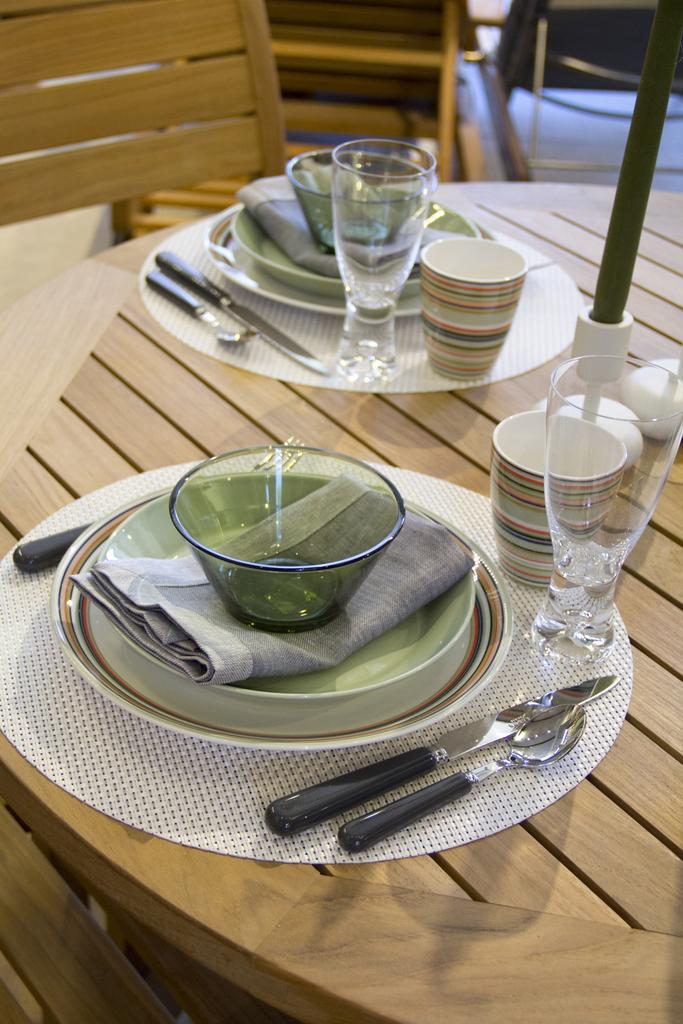What type of table is in the image? There is a brown table in the image. What objects are placed on the table? There are plates, glasses, and cups on the table. What type of seating is present in the image? There are chairs in the image. What color is the cushion on the chair in the image? There is no cushion present on the chairs in the image. How many mint leaves are on the table in the image? There are no mint leaves visible on the table in the image. 